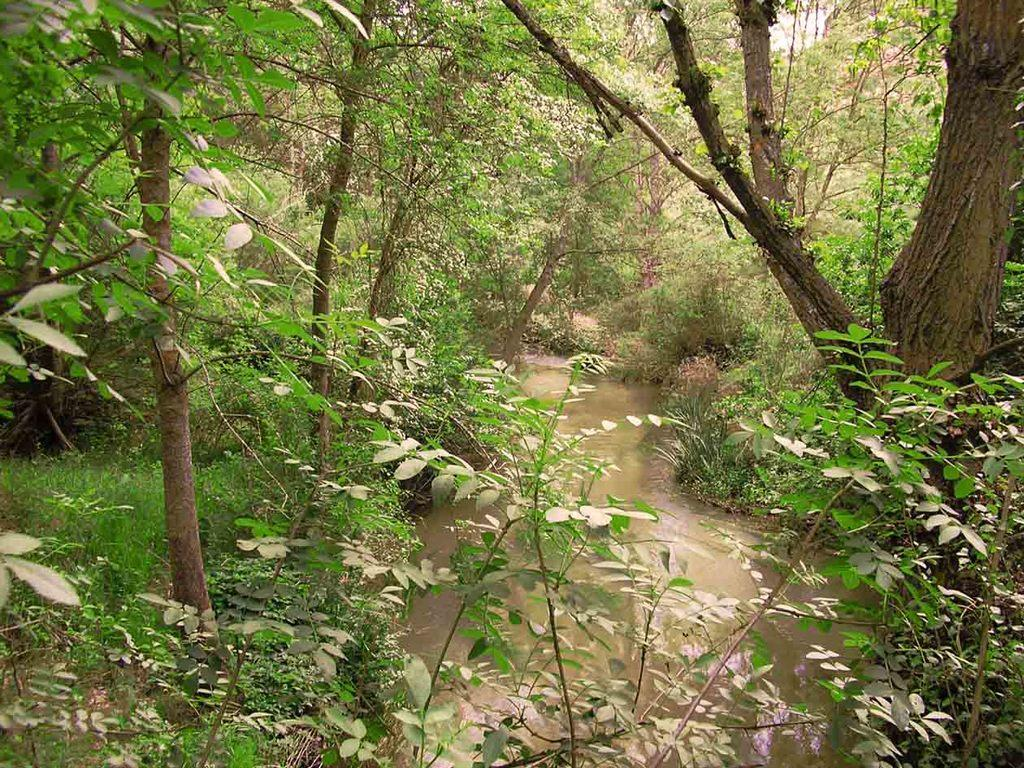What is happening in the image? There is there a water flow in the image. What type of vegetation can be seen in the image? There are plants and trees in the image. What type of banana is being used as a border in the image? There is no banana present in the image, nor is there is there any border. 